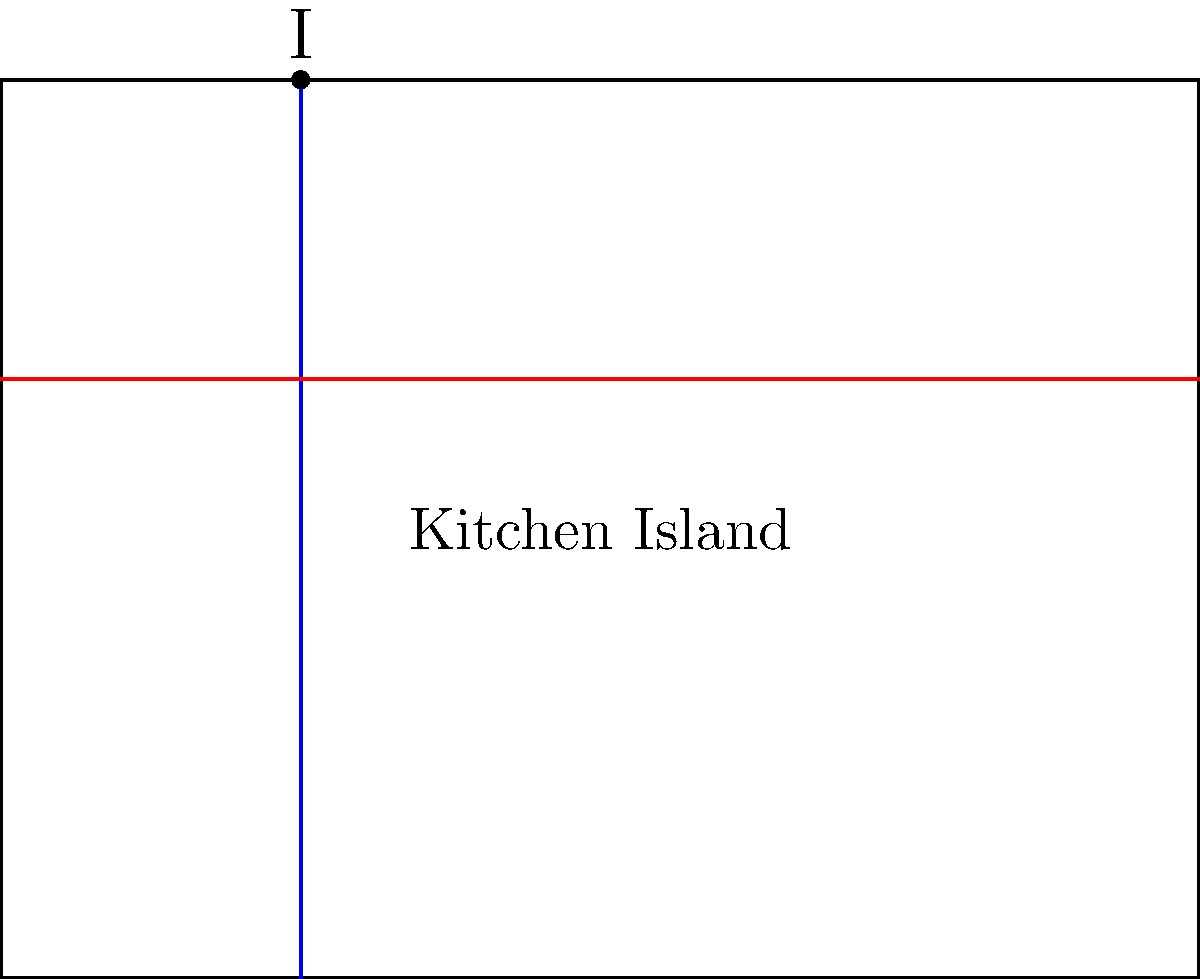On your kitchen island, you have placed two perpendicular cutting boards. The first cutting board (blue) is positioned 2 units from the left edge of the island, while the second cutting board (red) is positioned 4 units from the bottom edge. Given that the kitchen island measures 8 units wide and 6 units deep, determine the coordinates of the intersection point (I) of the two cutting boards. To find the intersection point of the two perpendicular cutting boards, we can follow these steps:

1) First, let's identify the equations of the lines representing each cutting board:

   Cutting Board 1 (blue): $x = 2$ (vertical line)
   Cutting Board 2 (red): $y = 4$ (horizontal line)

2) The intersection point (I) will satisfy both equations simultaneously. Therefore:

   $x = 2$
   $y = 4$

3) These coordinates $(2, 4)$ represent the point where the two cutting boards intersect.

4) To verify, we can see that this point is indeed 2 units from the left edge of the island (satisfying the equation of Cutting Board 1) and 4 units from the bottom edge of the island (satisfying the equation of Cutting Board 2).

Therefore, the intersection point I has coordinates (2, 4).
Answer: $(2, 4)$ 